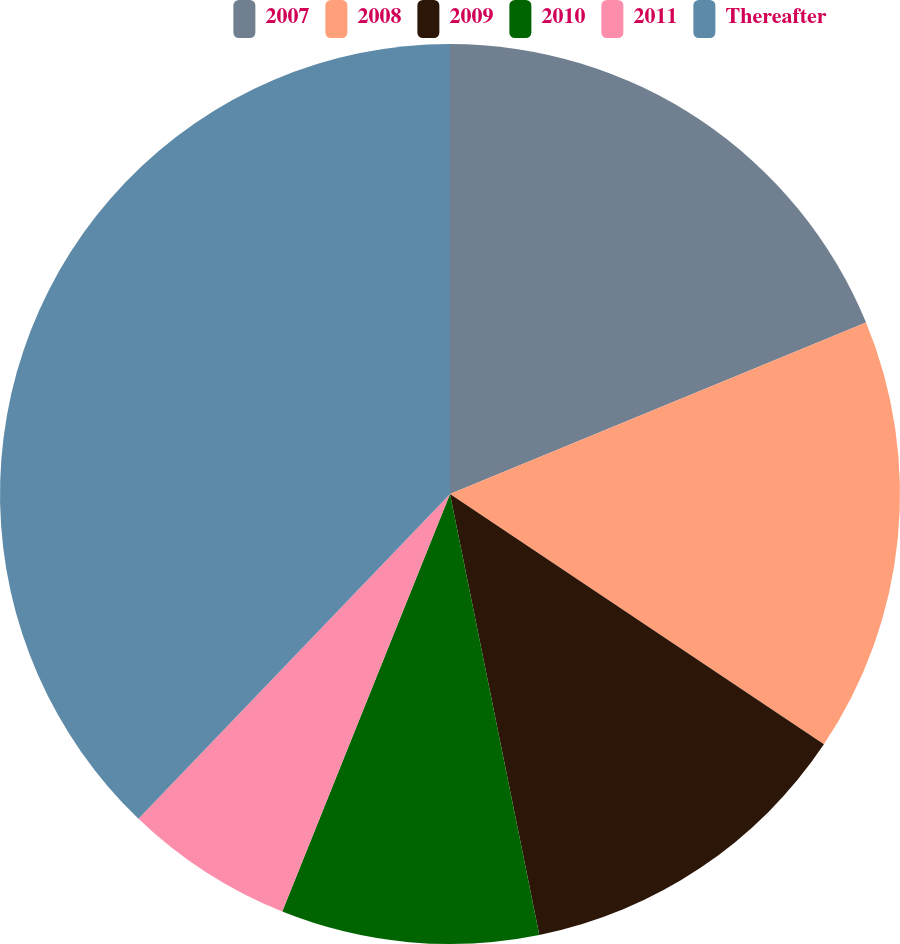Convert chart to OTSL. <chart><loc_0><loc_0><loc_500><loc_500><pie_chart><fcel>2007<fcel>2008<fcel>2009<fcel>2010<fcel>2011<fcel>Thereafter<nl><fcel>18.78%<fcel>15.61%<fcel>12.43%<fcel>9.26%<fcel>6.09%<fcel>37.83%<nl></chart> 